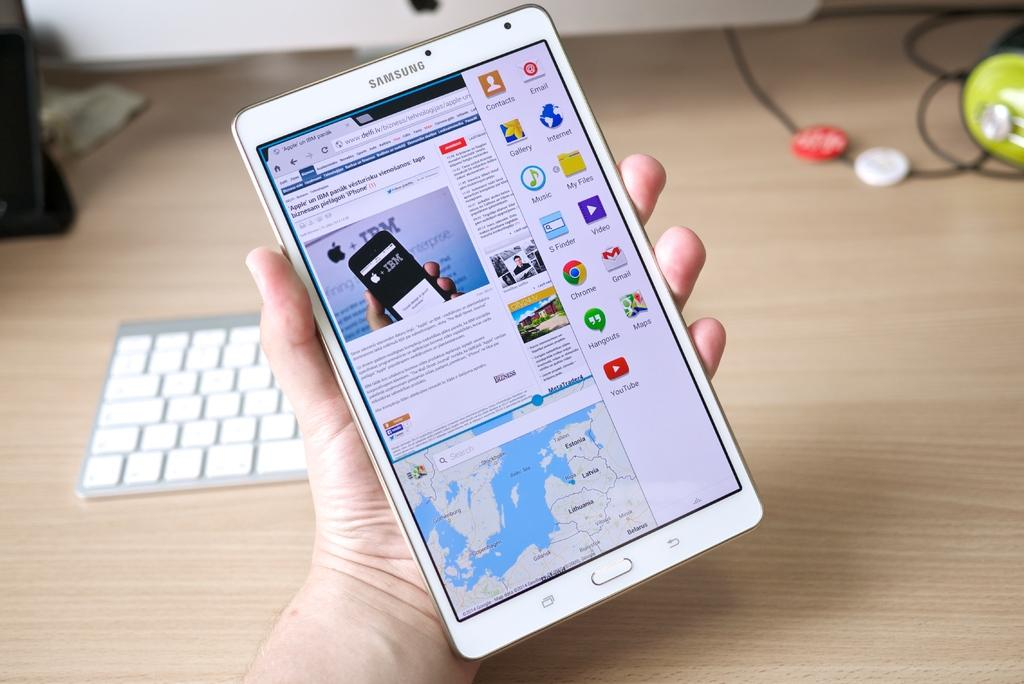What is the person holding in the image? There is a person's hand holding a cellphone in the image. What type of device is visible in the image? There is a keyboard and a computer in the image. What is the setting of the image? The image shows objects on a table, suggesting it is an indoor setting. Can you see a picture of a playground in the image? There is no picture of a playground present in the image. What type of care is being provided to the person in the image? There is no indication of any care being provided in the image, as it only shows a person's hand holding a cellphone, a keyboard, and a computer. 